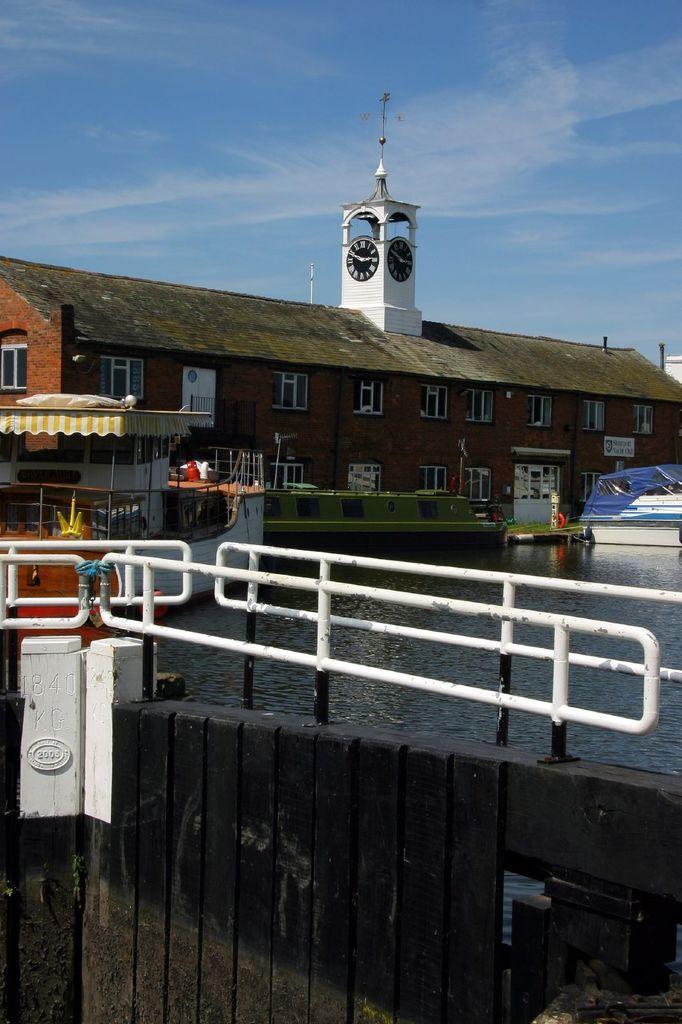Could you give a brief overview of what you see in this image? In this image we can see a wooden fence. Here we can see the boats floating on the water. In the background, we can see a brick house with a tower where a clock is fixed in the center and sky with clouds. 